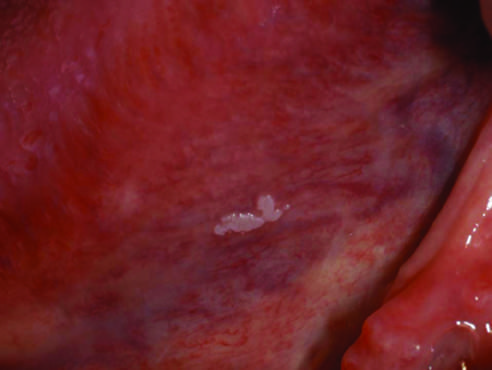what is smooth with well-demarcated borders and minimal elevation in this example?
Answer the question using a single word or phrase. The lesion 